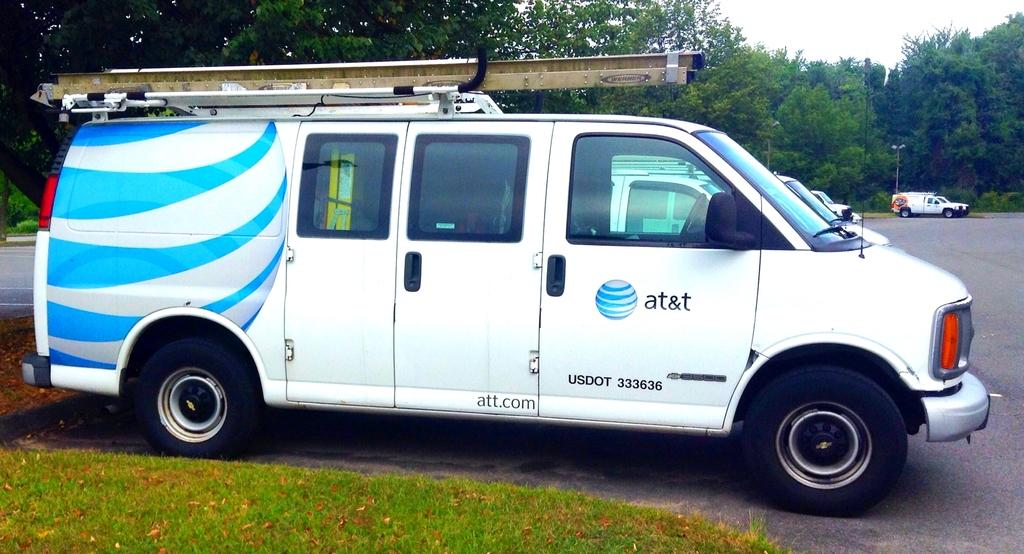Provide a one-sentence caption for the provided image. the word at&t that is on a truck. 